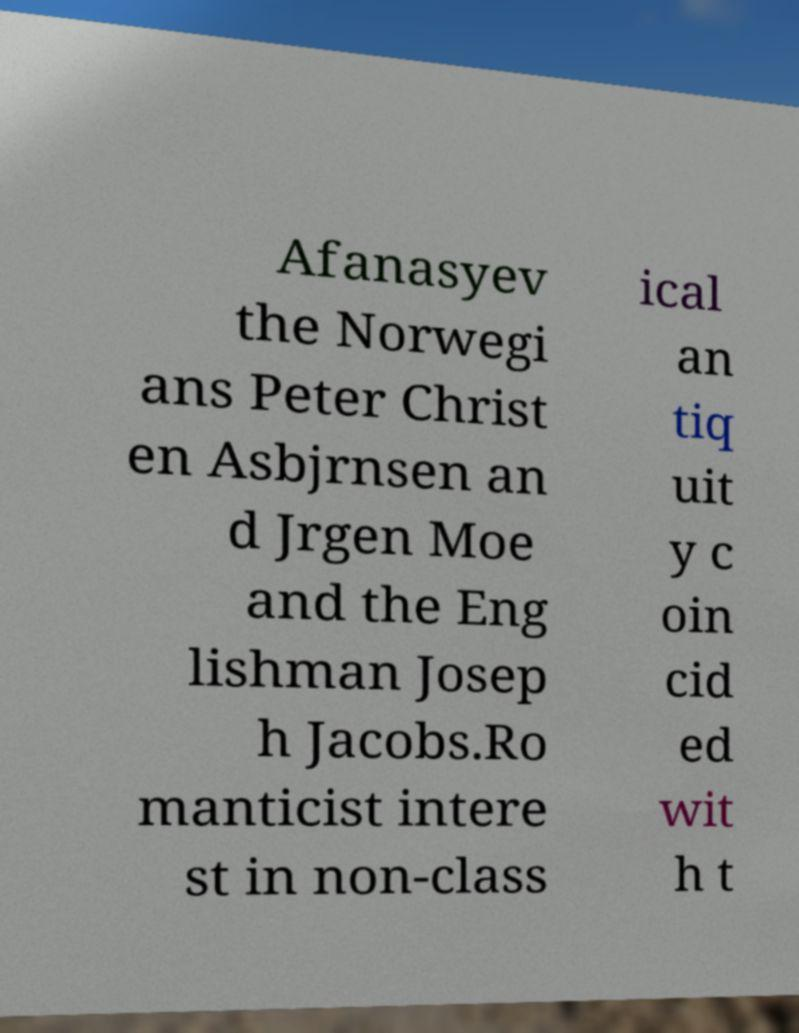Can you accurately transcribe the text from the provided image for me? Afanasyev the Norwegi ans Peter Christ en Asbjrnsen an d Jrgen Moe and the Eng lishman Josep h Jacobs.Ro manticist intere st in non-class ical an tiq uit y c oin cid ed wit h t 